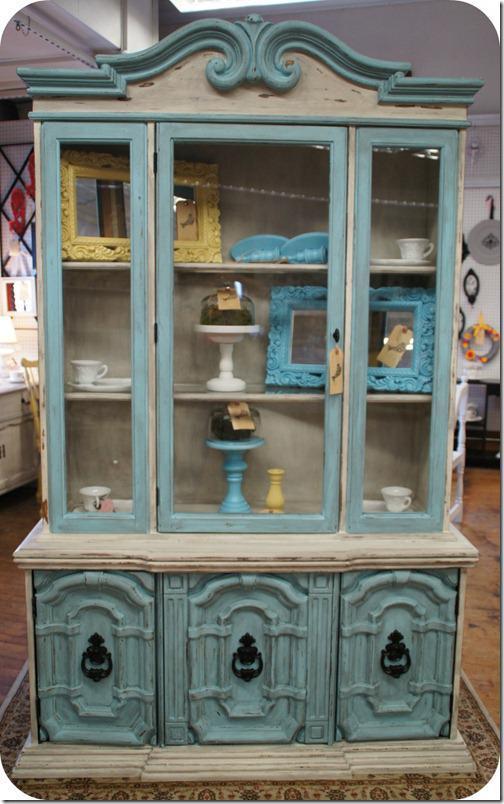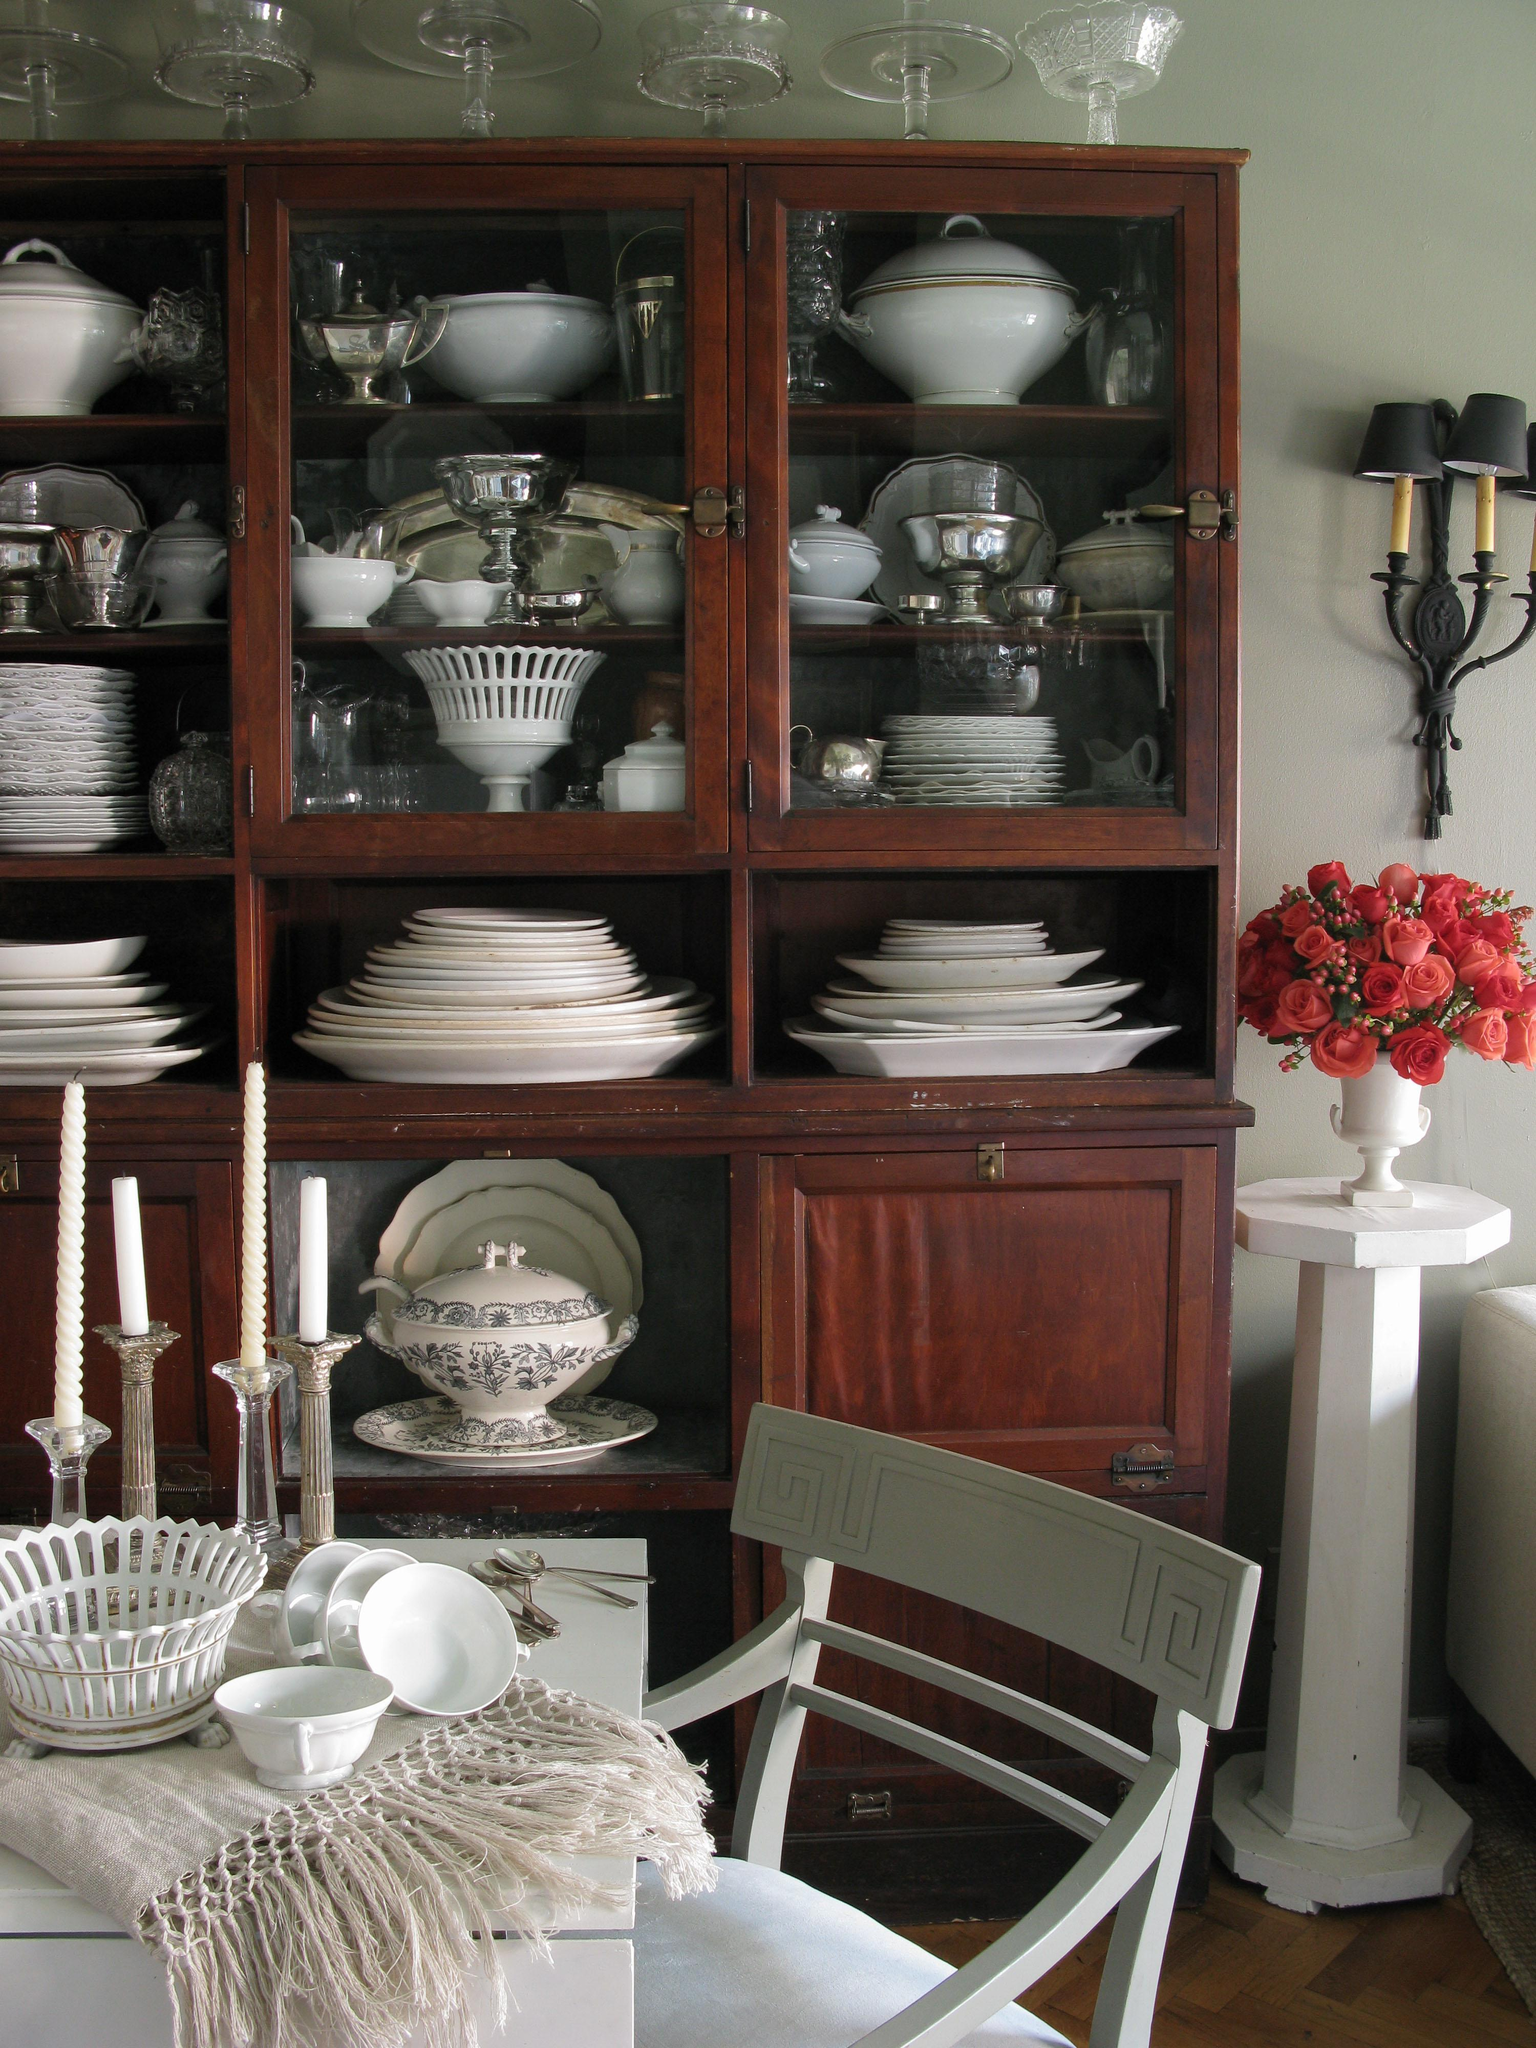The first image is the image on the left, the second image is the image on the right. Given the left and right images, does the statement "There is a plant on the side of the cabinet in the image on the left." hold true? Answer yes or no. No. The first image is the image on the left, the second image is the image on the right. Assess this claim about the two images: "At least one of the cabinets is greenish, with a flat top and scrollwork with legs at the bottom.". Correct or not? Answer yes or no. No. 